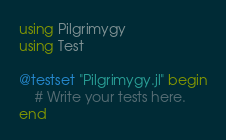Convert code to text. <code><loc_0><loc_0><loc_500><loc_500><_Julia_>using Pilgrimygy
using Test

@testset "Pilgrimygy.jl" begin
    # Write your tests here.
end</code> 